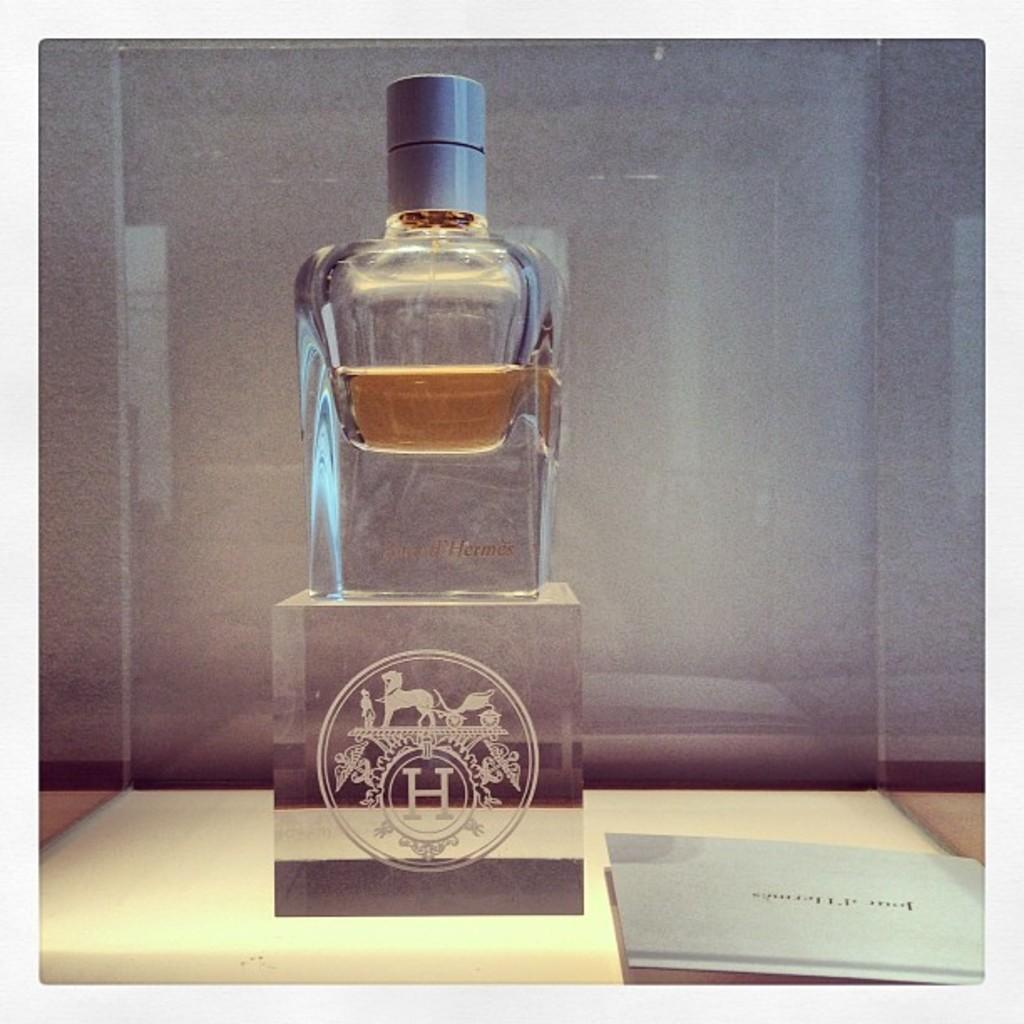What is on the stand with a logo in the image? There is a bottle on the stand with a logo in the image. Where is the bottle and stand located? The bottle and stand are on a table in the image. What else can be seen on the table? There is a paper on the table in the image. What type of degree is being awarded at the event in the image? There is no event or degree present in the image; it only shows a bottle on a stand with a logo on a table with a paper. 